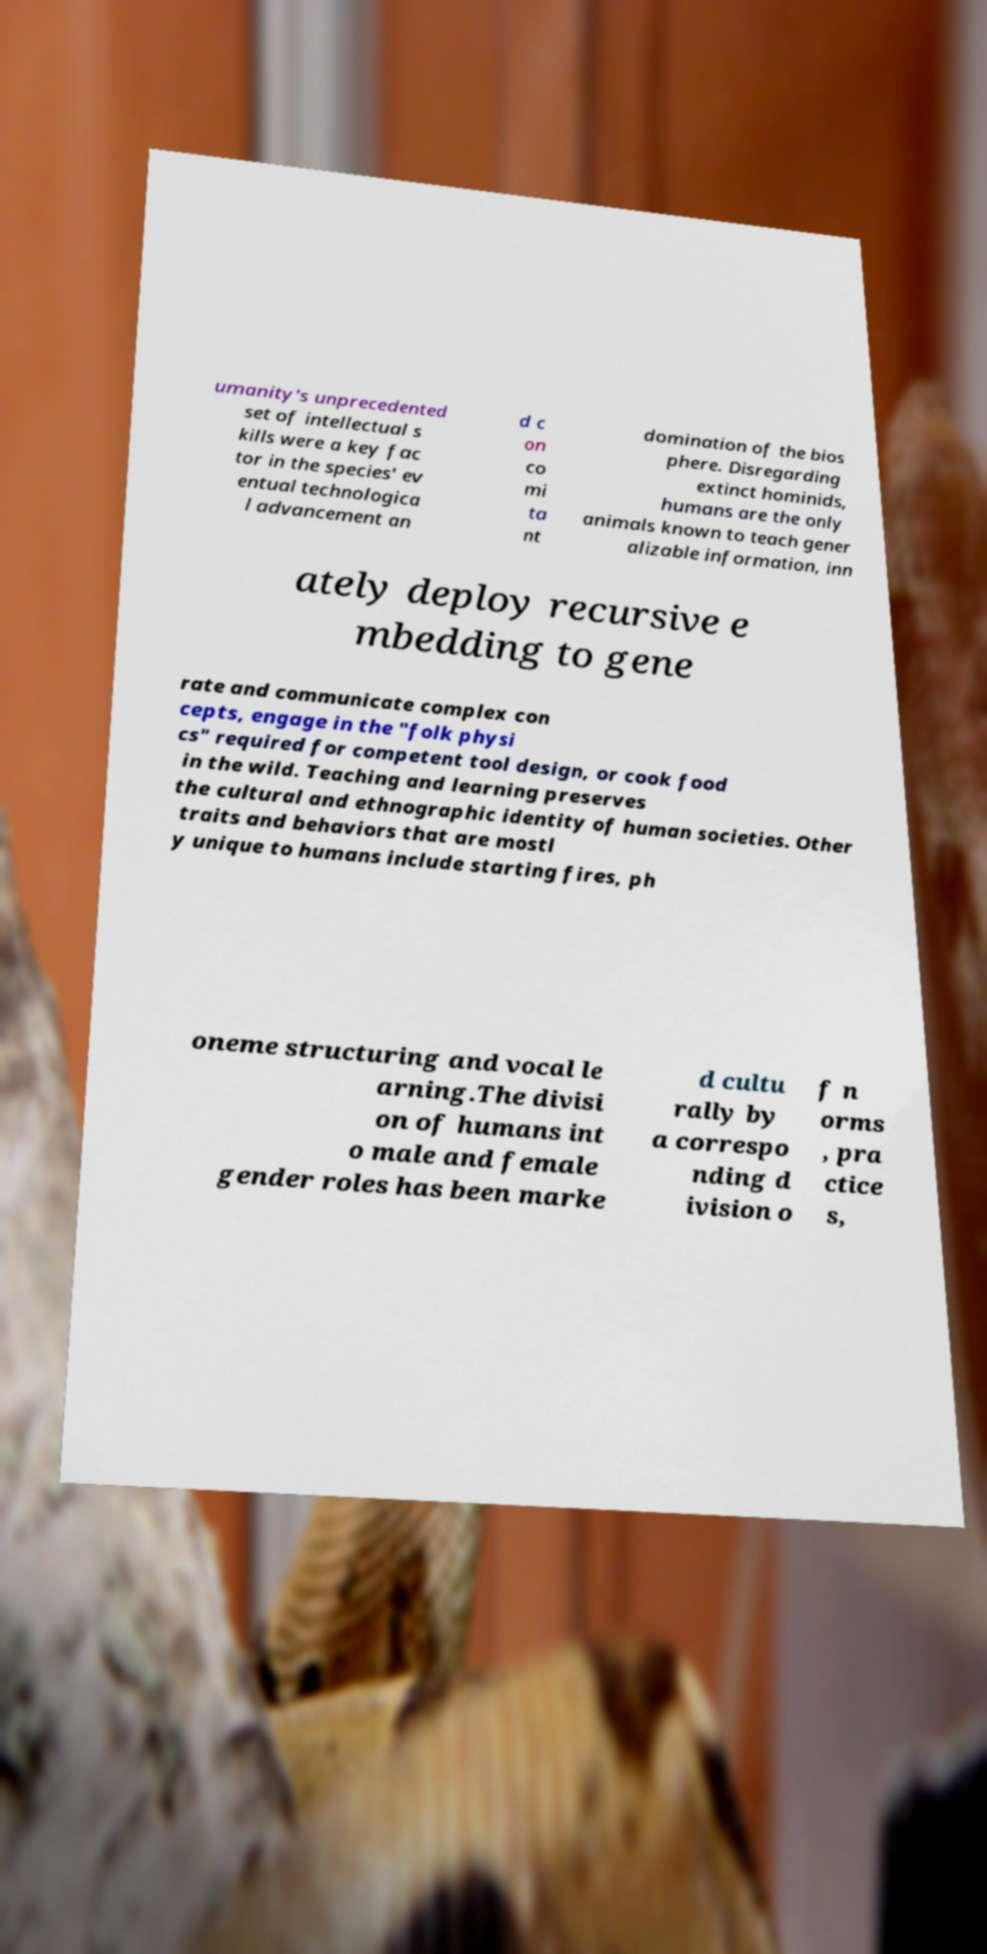Can you accurately transcribe the text from the provided image for me? umanity's unprecedented set of intellectual s kills were a key fac tor in the species' ev entual technologica l advancement an d c on co mi ta nt domination of the bios phere. Disregarding extinct hominids, humans are the only animals known to teach gener alizable information, inn ately deploy recursive e mbedding to gene rate and communicate complex con cepts, engage in the "folk physi cs" required for competent tool design, or cook food in the wild. Teaching and learning preserves the cultural and ethnographic identity of human societies. Other traits and behaviors that are mostl y unique to humans include starting fires, ph oneme structuring and vocal le arning.The divisi on of humans int o male and female gender roles has been marke d cultu rally by a correspo nding d ivision o f n orms , pra ctice s, 